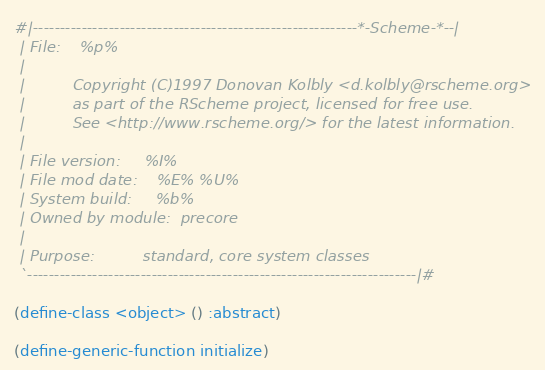Convert code to text. <code><loc_0><loc_0><loc_500><loc_500><_Scheme_>#|------------------------------------------------------------*-Scheme-*--|
 | File:    %p%
 |
 |          Copyright (C)1997 Donovan Kolbly <d.kolbly@rscheme.org>
 |          as part of the RScheme project, licensed for free use.
 |          See <http://www.rscheme.org/> for the latest information.
 |
 | File version:     %I%
 | File mod date:    %E% %U%
 | System build:     %b%
 | Owned by module:  precore
 |
 | Purpose:          standard, core system classes
 `------------------------------------------------------------------------|#

(define-class <object> () :abstract)

(define-generic-function initialize)</code> 